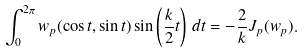Convert formula to latex. <formula><loc_0><loc_0><loc_500><loc_500>\int _ { 0 } ^ { 2 \pi } w _ { p } ( \cos t , \sin t ) \sin \left ( \frac { k } { 2 } t \right ) \, d t = - \frac { 2 } { k } J _ { p } ( w _ { p } ) .</formula> 